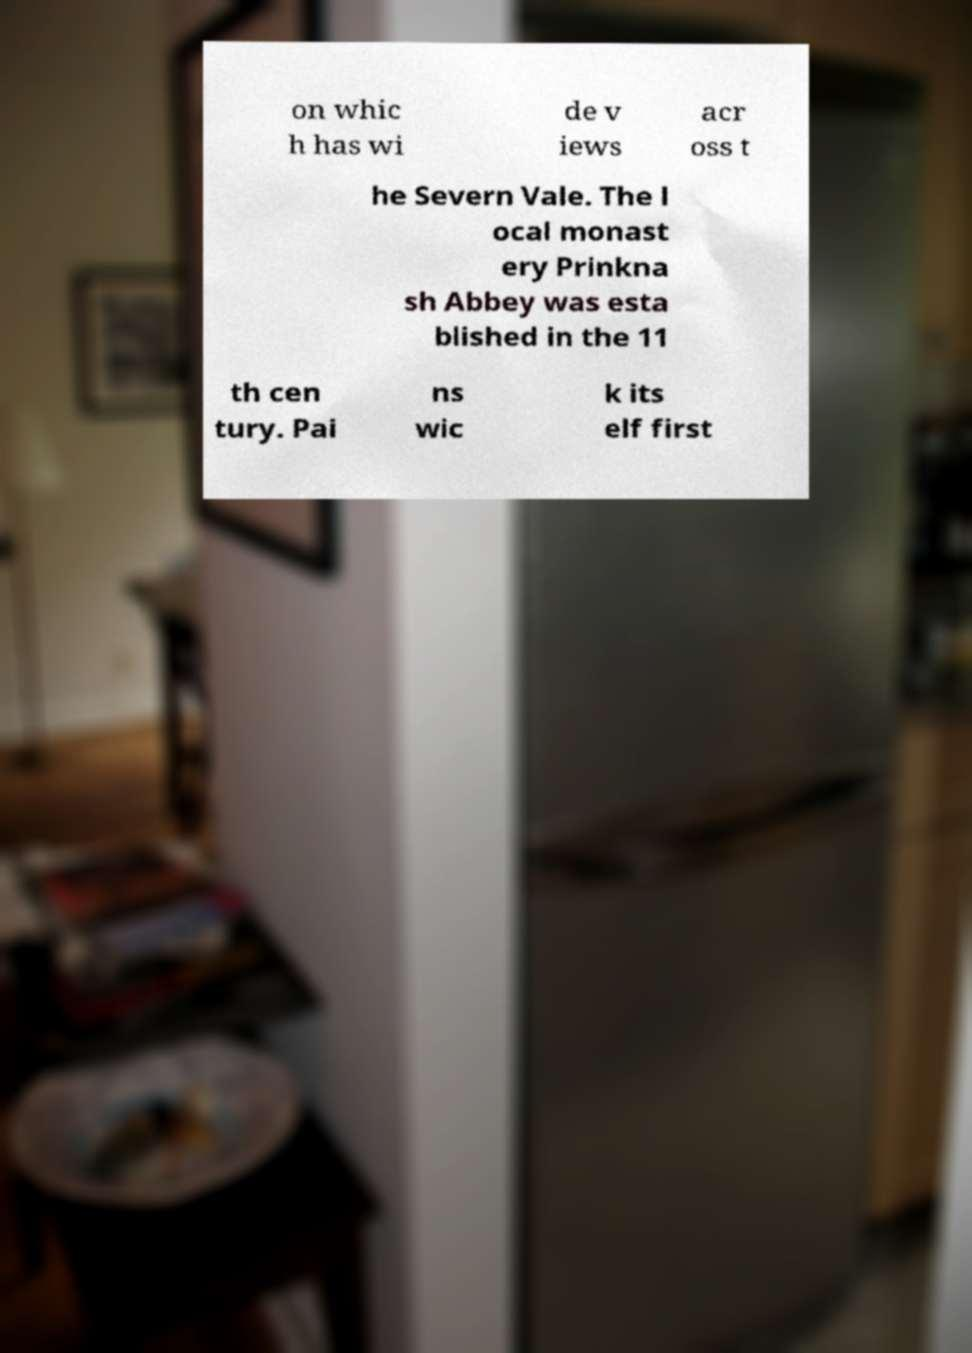What messages or text are displayed in this image? I need them in a readable, typed format. on whic h has wi de v iews acr oss t he Severn Vale. The l ocal monast ery Prinkna sh Abbey was esta blished in the 11 th cen tury. Pai ns wic k its elf first 